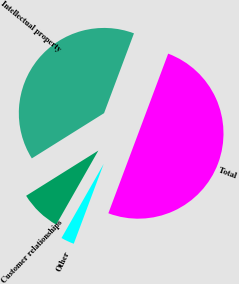Convert chart. <chart><loc_0><loc_0><loc_500><loc_500><pie_chart><fcel>Intellectual property<fcel>Customer relationships<fcel>Other<fcel>Total<nl><fcel>39.61%<fcel>7.86%<fcel>2.53%<fcel>50.0%<nl></chart> 